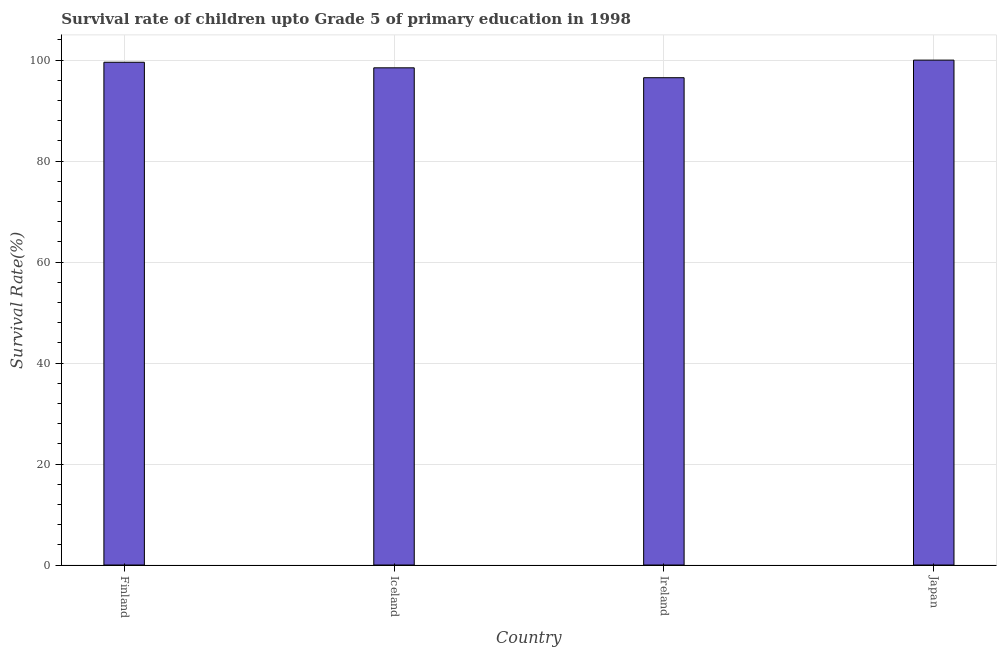Does the graph contain grids?
Your answer should be very brief. Yes. What is the title of the graph?
Make the answer very short. Survival rate of children upto Grade 5 of primary education in 1998 . What is the label or title of the X-axis?
Provide a succinct answer. Country. What is the label or title of the Y-axis?
Your answer should be very brief. Survival Rate(%). What is the survival rate in Japan?
Provide a short and direct response. 99.98. Across all countries, what is the maximum survival rate?
Your response must be concise. 99.98. Across all countries, what is the minimum survival rate?
Provide a succinct answer. 96.5. In which country was the survival rate minimum?
Provide a short and direct response. Ireland. What is the sum of the survival rate?
Your answer should be compact. 394.49. What is the difference between the survival rate in Iceland and Japan?
Your answer should be very brief. -1.53. What is the average survival rate per country?
Provide a succinct answer. 98.62. What is the median survival rate?
Ensure brevity in your answer.  99.01. What is the ratio of the survival rate in Iceland to that in Japan?
Your answer should be compact. 0.98. What is the difference between the highest and the second highest survival rate?
Provide a short and direct response. 0.42. What is the difference between the highest and the lowest survival rate?
Give a very brief answer. 3.48. In how many countries, is the survival rate greater than the average survival rate taken over all countries?
Your answer should be very brief. 2. How many bars are there?
Your response must be concise. 4. Are the values on the major ticks of Y-axis written in scientific E-notation?
Provide a succinct answer. No. What is the Survival Rate(%) in Finland?
Keep it short and to the point. 99.56. What is the Survival Rate(%) of Iceland?
Your answer should be very brief. 98.45. What is the Survival Rate(%) in Ireland?
Your response must be concise. 96.5. What is the Survival Rate(%) in Japan?
Your answer should be very brief. 99.98. What is the difference between the Survival Rate(%) in Finland and Iceland?
Your response must be concise. 1.1. What is the difference between the Survival Rate(%) in Finland and Ireland?
Give a very brief answer. 3.06. What is the difference between the Survival Rate(%) in Finland and Japan?
Keep it short and to the point. -0.42. What is the difference between the Survival Rate(%) in Iceland and Ireland?
Your answer should be very brief. 1.96. What is the difference between the Survival Rate(%) in Iceland and Japan?
Offer a very short reply. -1.53. What is the difference between the Survival Rate(%) in Ireland and Japan?
Keep it short and to the point. -3.48. What is the ratio of the Survival Rate(%) in Finland to that in Iceland?
Offer a very short reply. 1.01. What is the ratio of the Survival Rate(%) in Finland to that in Ireland?
Ensure brevity in your answer.  1.03. What is the ratio of the Survival Rate(%) in Iceland to that in Ireland?
Make the answer very short. 1.02. What is the ratio of the Survival Rate(%) in Iceland to that in Japan?
Your answer should be very brief. 0.98. 